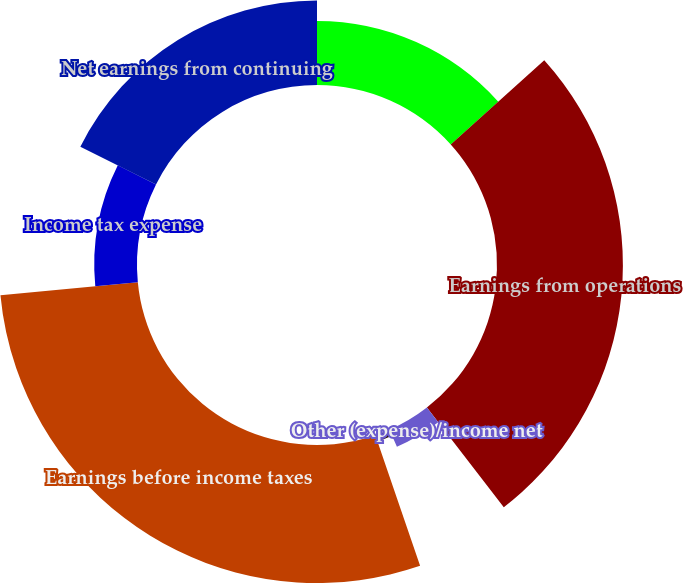Convert chart to OTSL. <chart><loc_0><loc_0><loc_500><loc_500><pie_chart><fcel>(Dollars in millions) Years<fcel>Earnings from operations<fcel>Other (expense)/income net<fcel>Interest and debt expense<fcel>Earnings before income taxes<fcel>Income tax expense<fcel>Net earnings from continuing<nl><fcel>13.33%<fcel>26.22%<fcel>3.86%<fcel>1.34%<fcel>28.74%<fcel>8.9%<fcel>17.62%<nl></chart> 